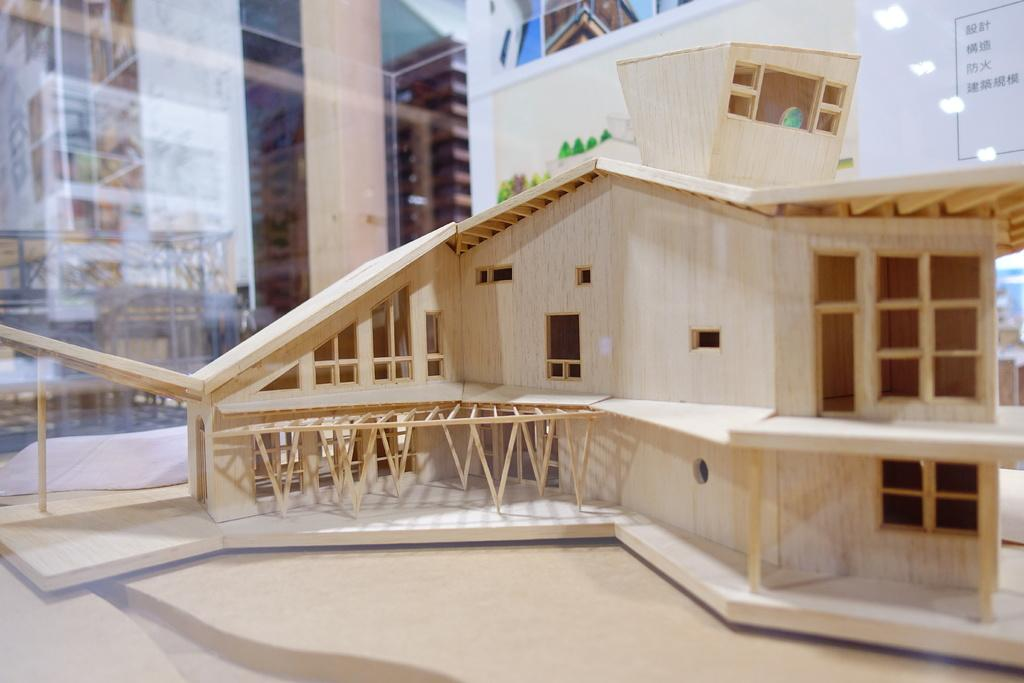What type of structure is depicted in the image? There is a scale model building in the image. Where is the scale model building located? The scale model building is on an object. What can be seen in the background of the image? There is a glass door and a board in the background of the image. What type of instrument is being played in the image? There is no instrument present in the image; it features a scale model building on an object with a glass door and a board in the background. 